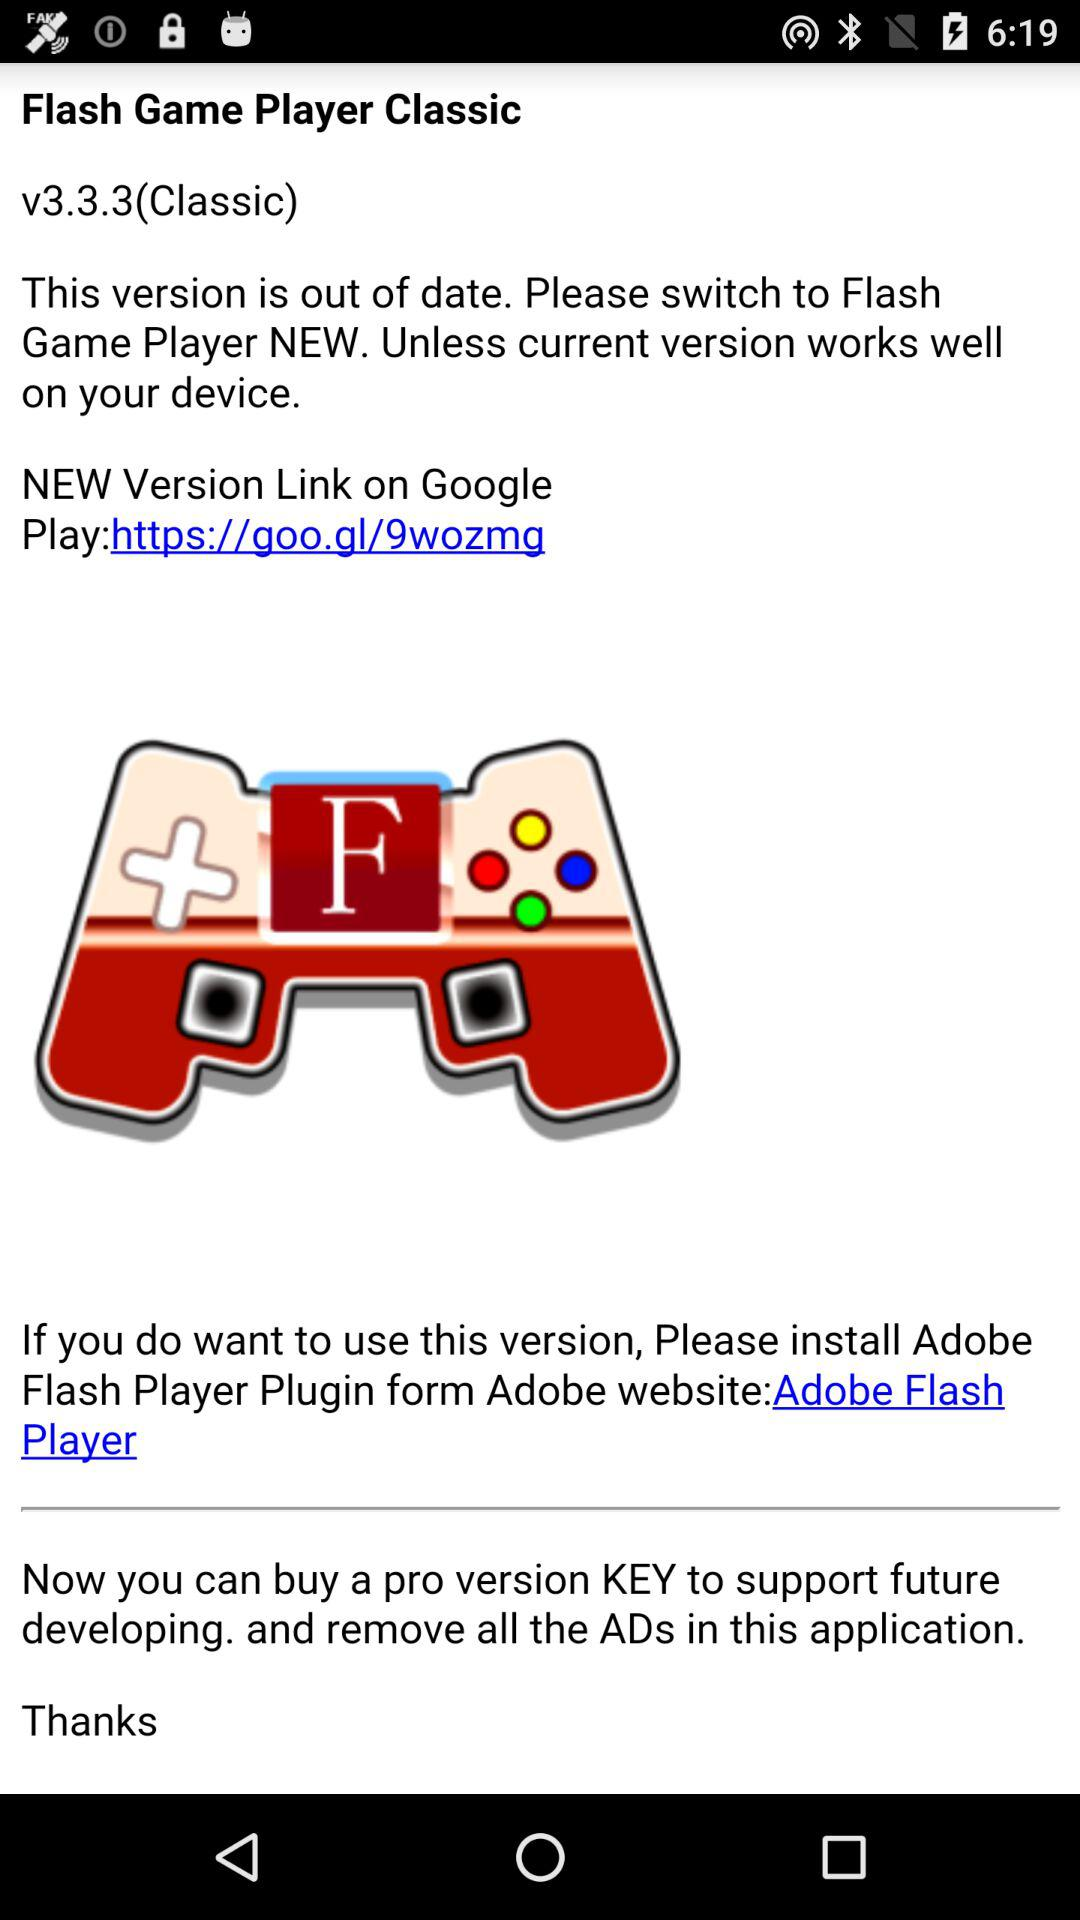What is the name of the application? The name of the application is "Flash Game Player Classic". 